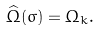Convert formula to latex. <formula><loc_0><loc_0><loc_500><loc_500>\widehat { \Omega } ( \sigma ) = \Omega _ { k } .</formula> 